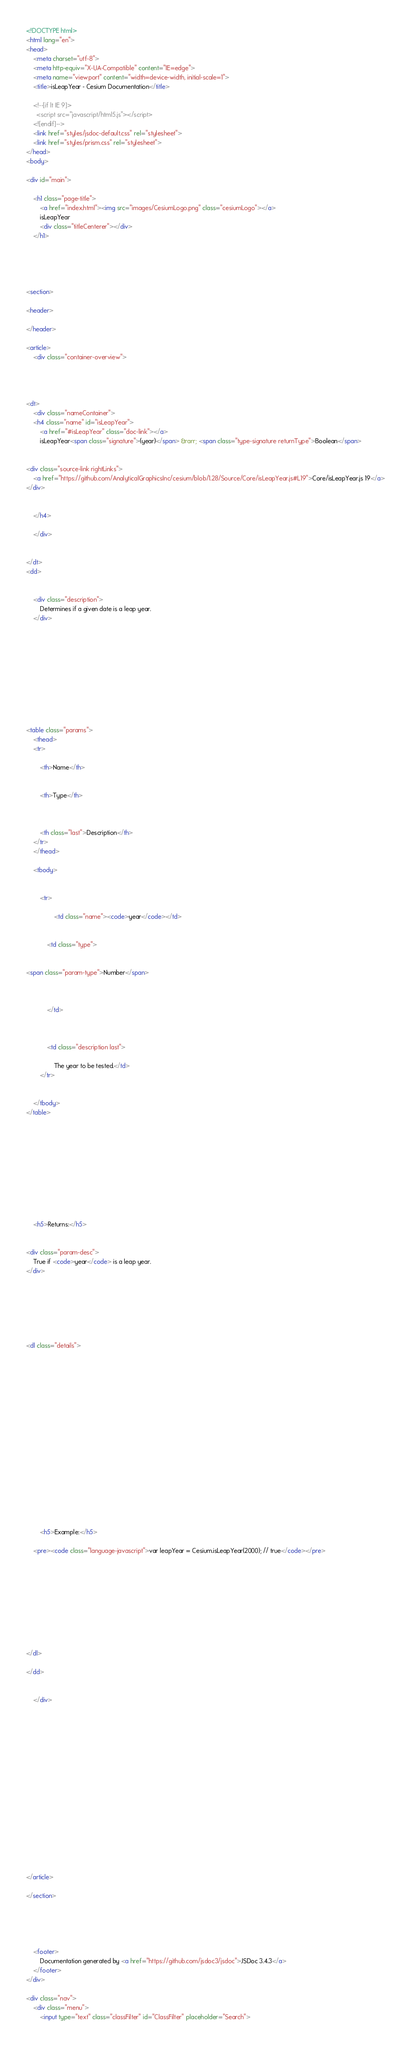Convert code to text. <code><loc_0><loc_0><loc_500><loc_500><_HTML_><!DOCTYPE html>
<html lang="en">
<head>
    <meta charset="utf-8">
    <meta http-equiv="X-UA-Compatible" content="IE=edge">
    <meta name="viewport" content="width=device-width, initial-scale=1">
    <title>isLeapYear - Cesium Documentation</title>

    <!--[if lt IE 9]>
      <script src="javascript/html5.js"></script>
    <![endif]-->
    <link href="styles/jsdoc-default.css" rel="stylesheet">
    <link href="styles/prism.css" rel="stylesheet">
</head>
<body>

<div id="main">

    <h1 class="page-title">
        <a href="index.html"><img src="images/CesiumLogo.png" class="cesiumLogo"></a>
        isLeapYear
        <div class="titleCenterer"></div>
    </h1>

    



<section>

<header>
    
</header>

<article>
    <div class="container-overview">
    

    
        
<dt>
    <div class="nameContainer">
    <h4 class="name" id="isLeapYear">
        <a href="#isLeapYear" class="doc-link"></a>
        isLeapYear<span class="signature">(year)</span> &rarr; <span class="type-signature returnType">Boolean</span>
        

<div class="source-link rightLinks">
    <a href="https://github.com/AnalyticalGraphicsInc/cesium/blob/1.28/Source/Core/isLeapYear.js#L19">Core/isLeapYear.js 19</a>
</div>


    </h4>

    </div>

    
</dt>
<dd>

    
    <div class="description">
        Determines if a given date is a leap year.
    </div>
    

    

    

    

    
        

<table class="params">
    <thead>
    <tr>
        
        <th>Name</th>
        

        <th>Type</th>

        

        <th class="last">Description</th>
    </tr>
    </thead>

    <tbody>
    

        <tr>
            
                <td class="name"><code>year</code></td>
            

            <td class="type">
            
                
<span class="param-type">Number</span>


            
            </td>

            

            <td class="description last">
            
                The year to be tested.</td>
        </tr>

    
    </tbody>
</table>
    

    

    

    

    

    
    <h5>Returns:</h5>
    
            
<div class="param-desc">
    True if <code>year</code> is a leap year.
</div>


        

    

    
<dl class="details">
    

    

    

    

    

    

    

    

    

    
        <h5>Example:</h5>
        
    <pre><code class="language-javascript">var leapYear = Cesium.isLeapYear(2000); // true</code></pre>

    

    

    

    

    
</dl>

</dd>

    
    </div>

    

    

    

    

    

    

    

    

    
</article>

</section>





    <footer>
        Documentation generated by <a href="https://github.com/jsdoc3/jsdoc">JSDoc 3.4.3</a>
    </footer>
</div>

<div class="nav">
    <div class="menu">
        <input type="text" class="classFilter" id="ClassFilter" placeholder="Search"></code> 